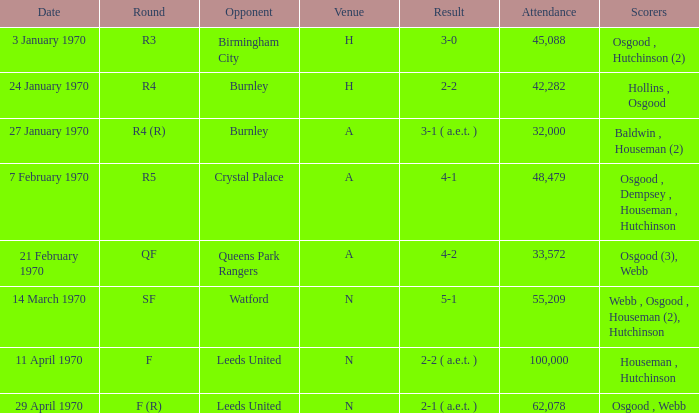What round was the match with a score of 5-1 at n location? SF. 